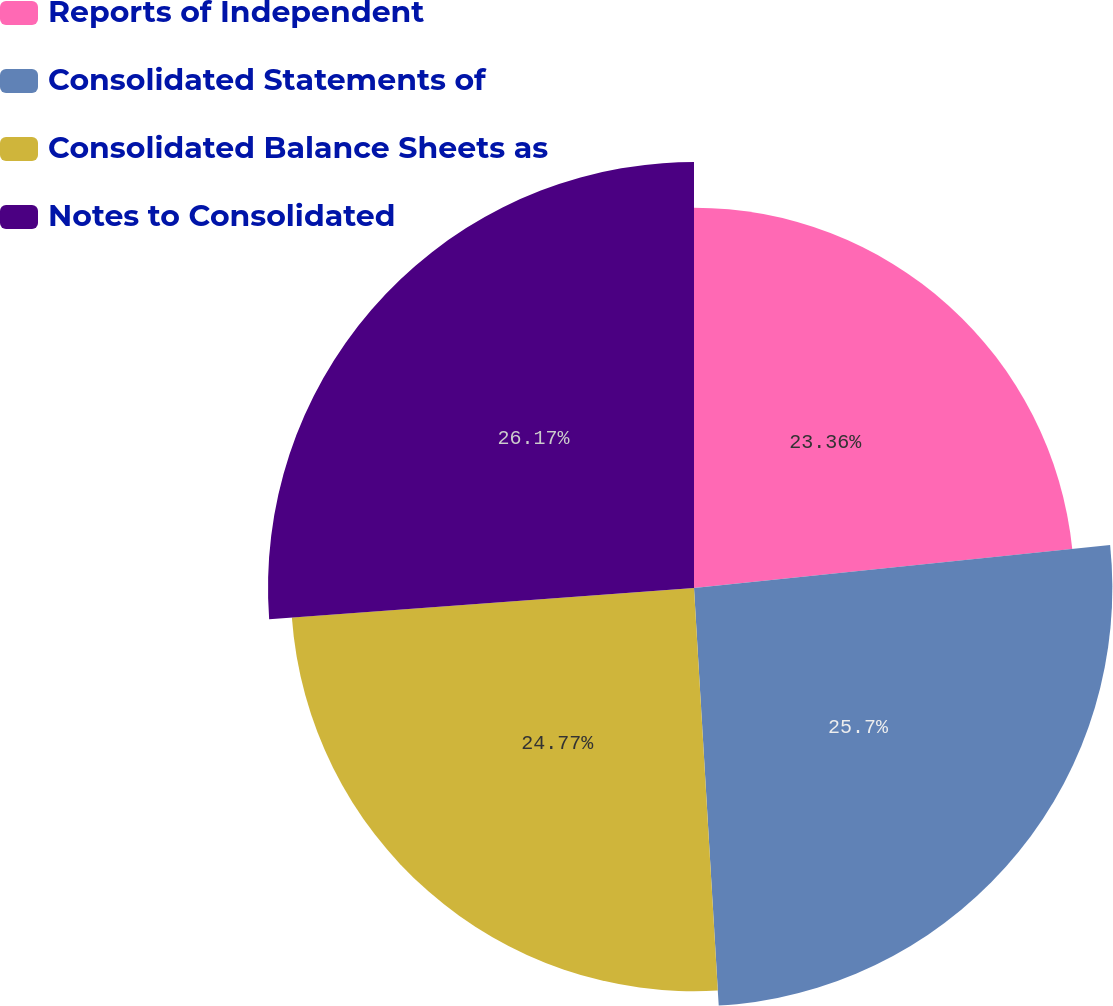<chart> <loc_0><loc_0><loc_500><loc_500><pie_chart><fcel>Reports of Independent<fcel>Consolidated Statements of<fcel>Consolidated Balance Sheets as<fcel>Notes to Consolidated<nl><fcel>23.36%<fcel>25.7%<fcel>24.77%<fcel>26.17%<nl></chart> 